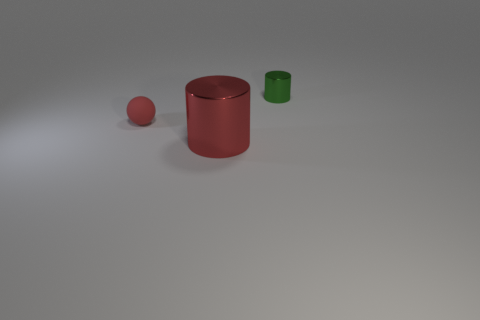There is a small thing on the left side of the metal thing to the right of the metallic object that is to the left of the green object; what shape is it?
Offer a terse response. Sphere. How big is the green cylinder?
Offer a terse response. Small. Does the red cylinder have the same size as the green object?
Offer a very short reply. No. What number of objects are objects that are to the left of the small shiny cylinder or tiny things right of the red cylinder?
Offer a very short reply. 3. There is a thing behind the tiny object that is on the left side of the green shiny thing; how many small red rubber balls are behind it?
Offer a terse response. 0. There is a red thing in front of the tiny red matte thing; what is its size?
Offer a very short reply. Large. How many green metal cylinders have the same size as the green metallic object?
Give a very brief answer. 0. There is a red rubber sphere; is its size the same as the object in front of the small ball?
Provide a succinct answer. No. How many objects are small rubber cubes or small green metallic objects?
Keep it short and to the point. 1. What number of metallic objects have the same color as the tiny cylinder?
Ensure brevity in your answer.  0. 